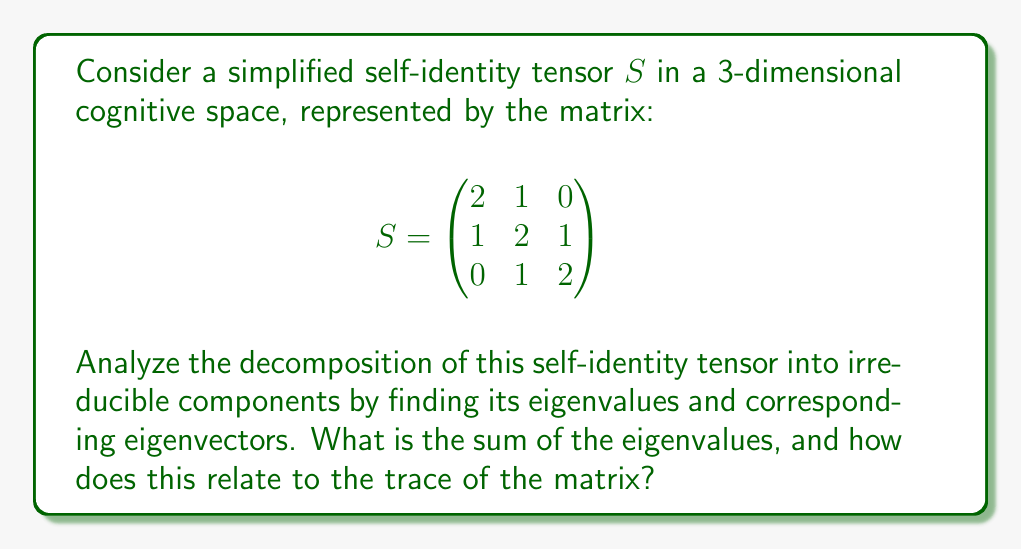Solve this math problem. 1) To find the eigenvalues, we solve the characteristic equation:
   $$\det(S - \lambda I) = 0$$

2) Expanding the determinant:
   $$\begin{vmatrix}
   2-\lambda & 1 & 0 \\
   1 & 2-\lambda & 1 \\
   0 & 1 & 2-\lambda
   \end{vmatrix} = 0$$

3) This gives us the characteristic polynomial:
   $$(2-\lambda)^3 - 2(2-\lambda) - 2 = 0$$
   $$\lambda^3 - 6\lambda^2 + 11\lambda - 6 = 0$$

4) Factoring this polynomial:
   $$(\lambda - 1)(\lambda - 2)(\lambda - 3) = 0$$

5) Therefore, the eigenvalues are $\lambda_1 = 1$, $\lambda_2 = 2$, and $\lambda_3 = 3$.

6) The sum of the eigenvalues is:
   $$1 + 2 + 3 = 6$$

7) The trace of the matrix $S$ is the sum of its diagonal elements:
   $$\text{tr}(S) = 2 + 2 + 2 = 6$$

8) We observe that the sum of the eigenvalues equals the trace of the matrix, which is a general property for all square matrices.

9) Each eigenvalue corresponds to an irreducible component of the self-identity tensor, representing a fundamental aspect of cognitive self-identity in this simplified model.
Answer: $\sum \lambda_i = \text{tr}(S) = 6$ 